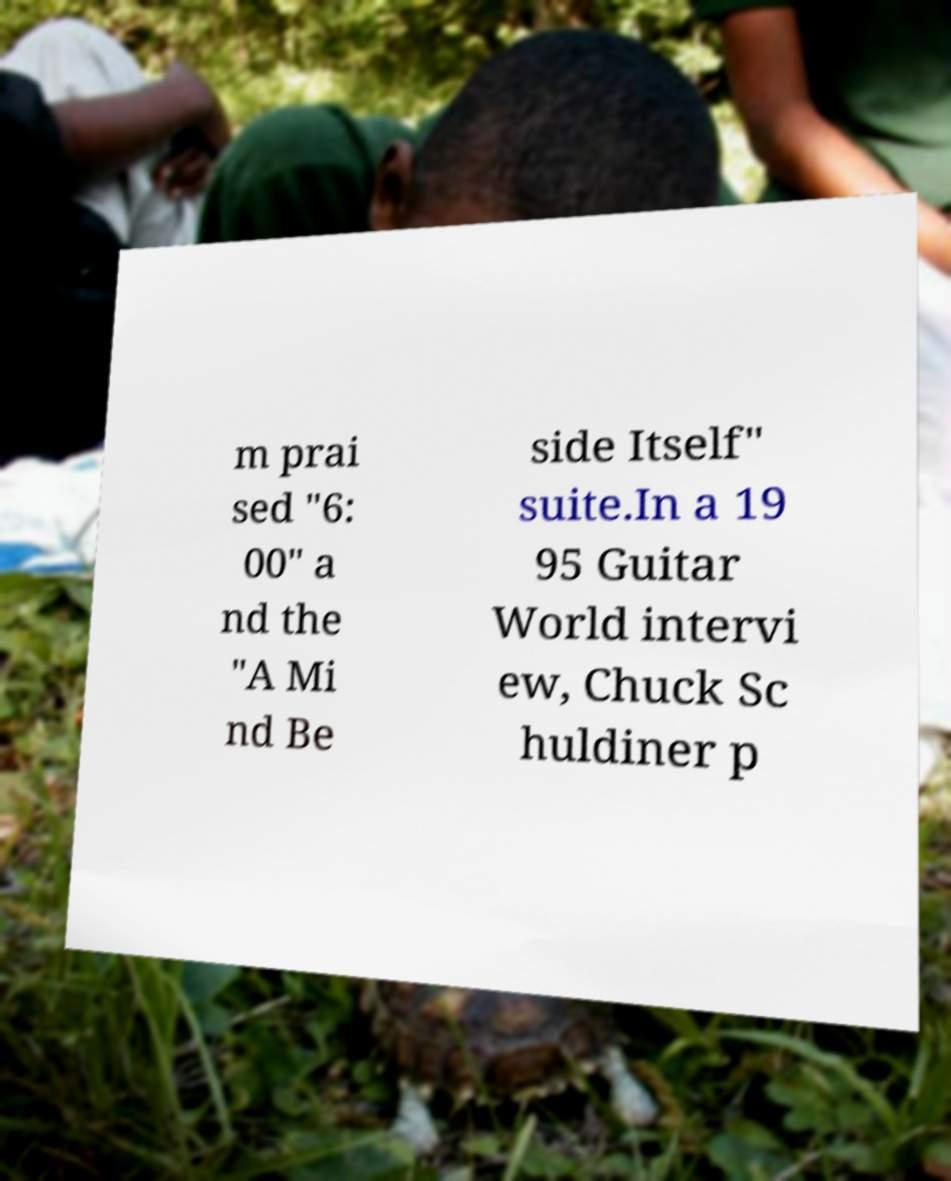Can you accurately transcribe the text from the provided image for me? m prai sed "6: 00" a nd the "A Mi nd Be side Itself" suite.In a 19 95 Guitar World intervi ew, Chuck Sc huldiner p 